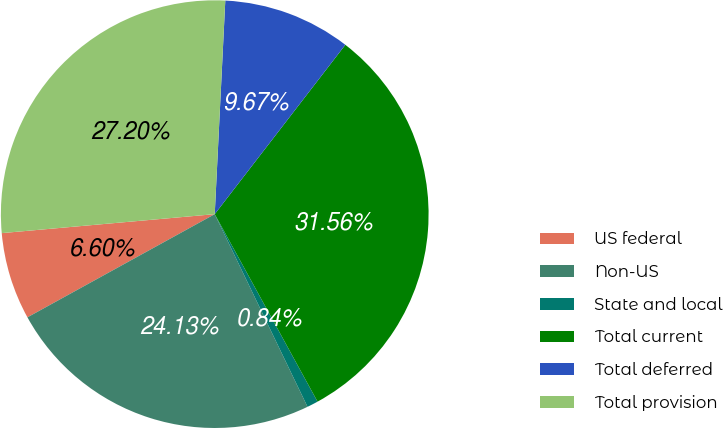<chart> <loc_0><loc_0><loc_500><loc_500><pie_chart><fcel>US federal<fcel>Non-US<fcel>State and local<fcel>Total current<fcel>Total deferred<fcel>Total provision<nl><fcel>6.6%<fcel>24.13%<fcel>0.84%<fcel>31.56%<fcel>9.67%<fcel>27.2%<nl></chart> 